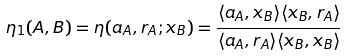<formula> <loc_0><loc_0><loc_500><loc_500>\eta _ { 1 } ( A , B ) = \eta ( a _ { A } , r _ { A } ; x _ { B } ) = \frac { \langle { a } _ { A } , { x } _ { B } \rangle \langle { x } _ { B } , { r } _ { A } \rangle } { \langle { a } _ { A } , { r } _ { A } \rangle \langle { x } _ { B } , { x } _ { B } \rangle } \\</formula> 